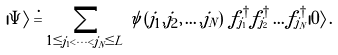<formula> <loc_0><loc_0><loc_500><loc_500>| \Psi \rangle \doteq \sum _ { 1 \leq j _ { 1 } < \dots < j _ { N } \leq L } \psi \left ( j _ { 1 } , j _ { 2 } , \dots , j _ { N } \right ) \, f _ { j _ { 1 } } ^ { \, \dagger } f _ { j _ { 2 } } ^ { \, \dagger } \dots f _ { j _ { N } } ^ { \, \dagger } | 0 \rangle \, .</formula> 